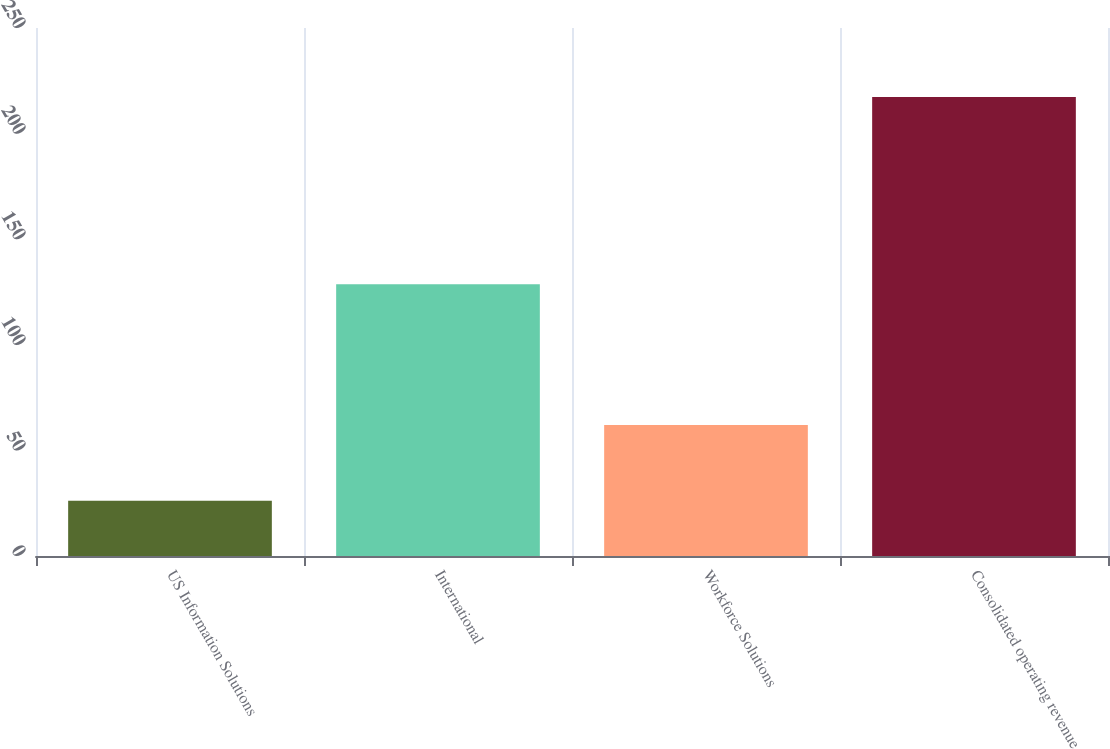Convert chart. <chart><loc_0><loc_0><loc_500><loc_500><bar_chart><fcel>US Information Solutions<fcel>International<fcel>Workforce Solutions<fcel>Consolidated operating revenue<nl><fcel>26.2<fcel>128.7<fcel>62<fcel>217.3<nl></chart> 